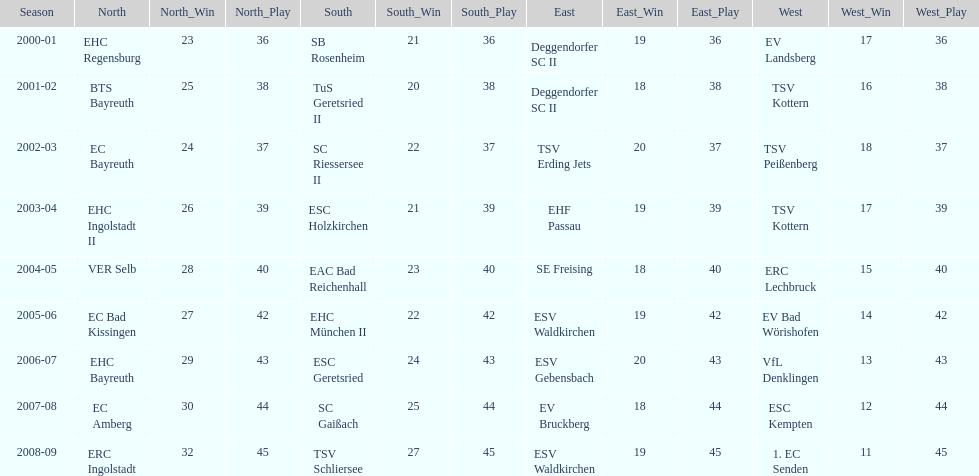The only team to win the north in 2000-01 season? EHC Regensburg. Can you give me this table as a dict? {'header': ['Season', 'North', 'North_Win', 'North_Play', 'South', 'South_Win', 'South_Play', 'East', 'East_Win', 'East_Play', 'West', 'West_Win', 'West_Play'], 'rows': [['2000-01', 'EHC Regensburg', '23', '36', 'SB Rosenheim', '21', '36', 'Deggendorfer SC II', '19', '36', 'EV Landsberg', '17', '36'], ['2001-02', 'BTS Bayreuth', '25', '38', 'TuS Geretsried II', '20', '38', 'Deggendorfer SC II', '18', '38', 'TSV Kottern', '16', '38'], ['2002-03', 'EC Bayreuth', '24', '37', 'SC Riessersee II', '22', '37', 'TSV Erding Jets', '20', '37', 'TSV Peißenberg', '18', '37'], ['2003-04', 'EHC Ingolstadt II', '26', '39', 'ESC Holzkirchen', '21', '39', 'EHF Passau', '19', '39', 'TSV Kottern', '17', '39'], ['2004-05', 'VER Selb', '28', '40', 'EAC Bad Reichenhall', '23', '40', 'SE Freising', '18', '40', 'ERC Lechbruck', '15', '40'], ['2005-06', 'EC Bad Kissingen', '27', '42', 'EHC München II', '22', '42', 'ESV Waldkirchen', '19', '42', 'EV Bad Wörishofen', '14', '42'], ['2006-07', 'EHC Bayreuth', '29', '43', 'ESC Geretsried', '24', '43', 'ESV Gebensbach', '20', '43', 'VfL Denklingen', '13', '43'], ['2007-08', 'EC Amberg', '30', '44', 'SC Gaißach', '25', '44', 'EV Bruckberg', '18', '44', 'ESC Kempten', '12', '44'], ['2008-09', 'ERC Ingolstadt', '32', '45', 'TSV Schliersee', '27', '45', 'ESV Waldkirchen', '19', '45', '1. EC Senden', '11', '45']]} 